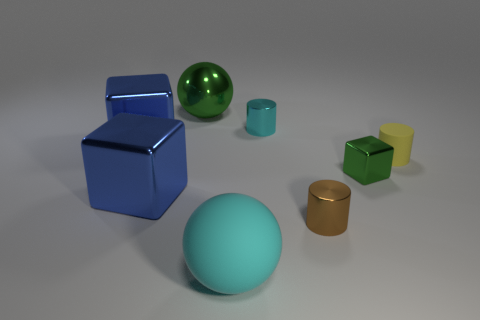What number of tiny objects are brown things or purple shiny spheres?
Provide a short and direct response. 1. What is the size of the cyan object that is the same shape as the tiny yellow thing?
Provide a succinct answer. Small. What is the shape of the tiny cyan metallic object?
Provide a short and direct response. Cylinder. Does the big green thing have the same material as the cyan object that is in front of the cyan cylinder?
Your response must be concise. No. How many rubber objects are large balls or small things?
Your answer should be very brief. 2. There is a rubber object that is on the left side of the tiny rubber cylinder; what size is it?
Provide a succinct answer. Large. There is a green cube that is made of the same material as the brown object; what is its size?
Keep it short and to the point. Small. What number of big shiny objects are the same color as the tiny metallic block?
Ensure brevity in your answer.  1. Is there a big cyan rubber object?
Ensure brevity in your answer.  Yes. Do the small yellow matte object and the green metallic thing that is to the left of the big cyan object have the same shape?
Provide a succinct answer. No. 